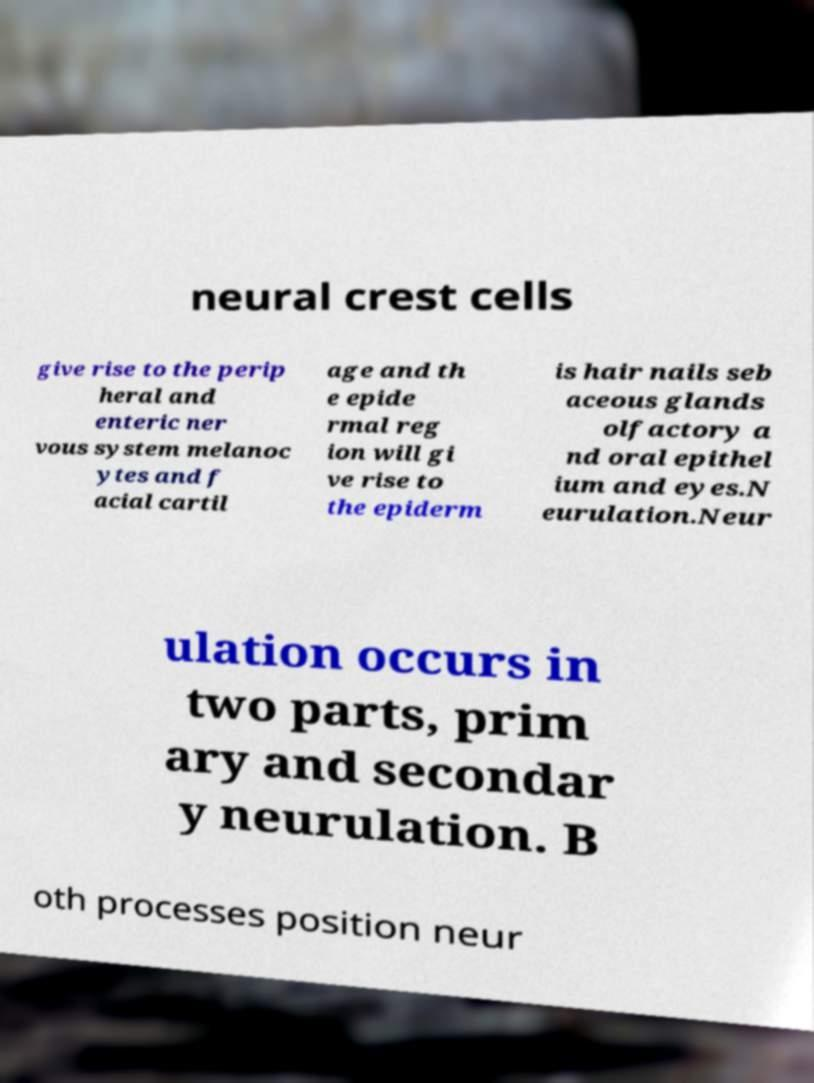Could you assist in decoding the text presented in this image and type it out clearly? neural crest cells give rise to the perip heral and enteric ner vous system melanoc ytes and f acial cartil age and th e epide rmal reg ion will gi ve rise to the epiderm is hair nails seb aceous glands olfactory a nd oral epithel ium and eyes.N eurulation.Neur ulation occurs in two parts, prim ary and secondar y neurulation. B oth processes position neur 